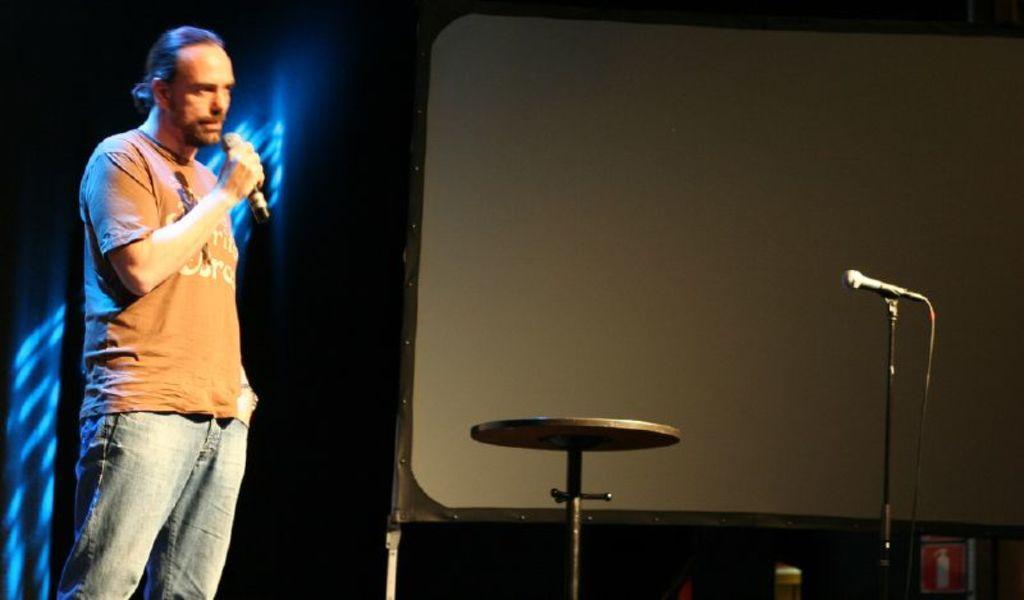Who is present in the image? There is a man in the image. What is the man doing in the image? The man is standing and speaking in the image. What object is associated with the man's speaking activity? There is a microphone in the image. What type of goldfish can be seen swimming around the man in the image? There is no goldfish present in the image; it features a man standing and speaking with a microphone. What type of ring is the man wearing on his finger in the image? There is no ring visible on the man's finger in the image. 